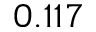Convert formula to latex. <formula><loc_0><loc_0><loc_500><loc_500>0 . 1 1 7</formula> 